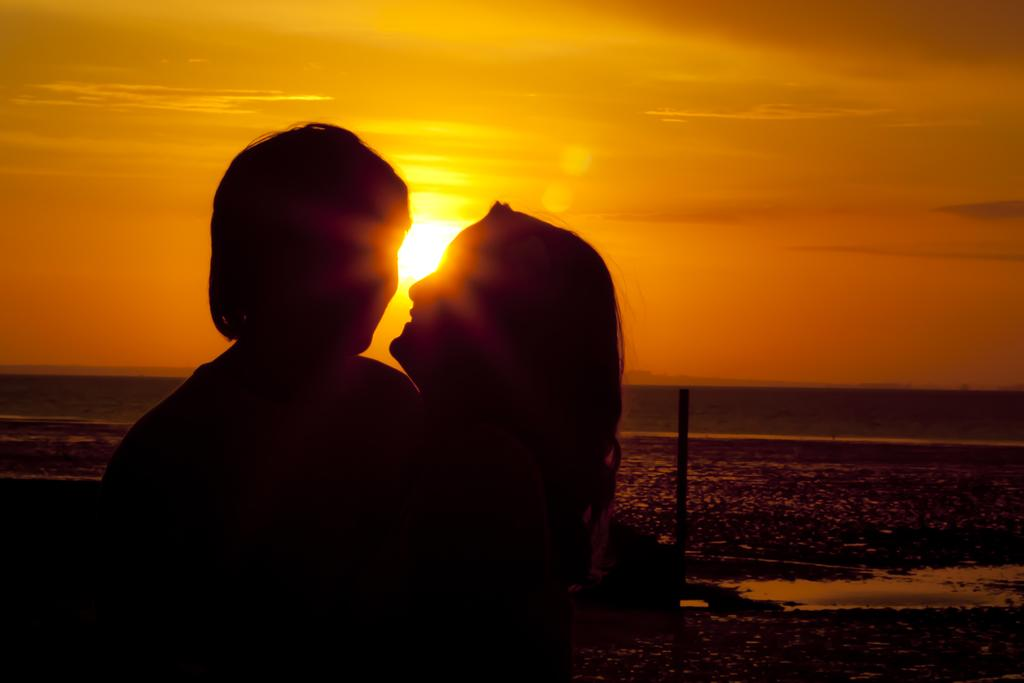Who or what can be seen in the foreground of the image? There are people in the foreground of the image. What can be seen in the background of the image? There is sky and water visible in the background of the image. Can the sun be seen in the image? Yes, the sun is observable in the background of the image. What type of bead is being used to start the low-temperature experiment in the image? There is no bead, experiment, or mention of temperature in the image; it features people in the foreground and sky, water, and the sun in the background. 